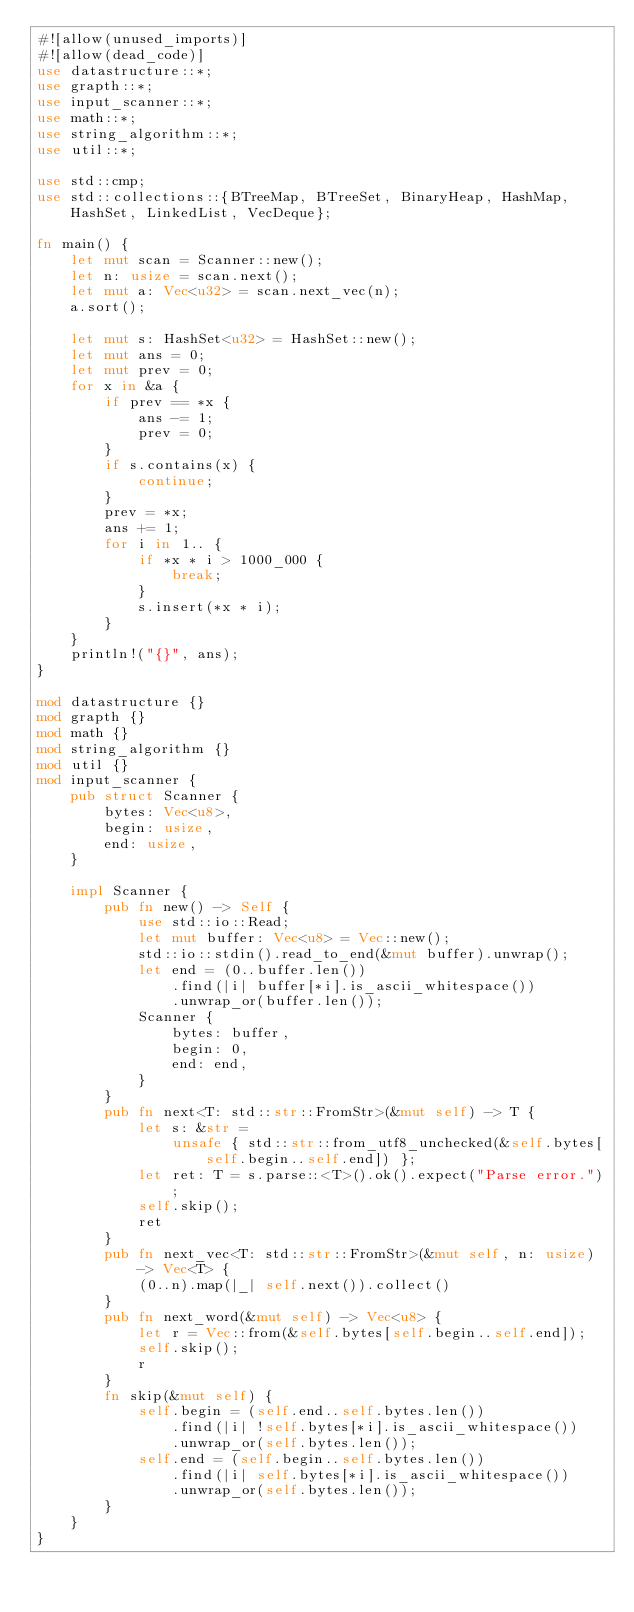Convert code to text. <code><loc_0><loc_0><loc_500><loc_500><_Rust_>#![allow(unused_imports)]
#![allow(dead_code)]
use datastructure::*;
use grapth::*;
use input_scanner::*;
use math::*;
use string_algorithm::*;
use util::*;

use std::cmp;
use std::collections::{BTreeMap, BTreeSet, BinaryHeap, HashMap, HashSet, LinkedList, VecDeque};

fn main() {
    let mut scan = Scanner::new();
    let n: usize = scan.next();
    let mut a: Vec<u32> = scan.next_vec(n);
    a.sort();

    let mut s: HashSet<u32> = HashSet::new();
    let mut ans = 0;
    let mut prev = 0;
    for x in &a {
        if prev == *x {
            ans -= 1;
            prev = 0;
        }
        if s.contains(x) {
            continue;
        }
        prev = *x;
        ans += 1;
        for i in 1.. {
            if *x * i > 1000_000 {
                break;
            }
            s.insert(*x * i);
        }
    }
    println!("{}", ans);
}

mod datastructure {}
mod grapth {}
mod math {}
mod string_algorithm {}
mod util {}
mod input_scanner {
    pub struct Scanner {
        bytes: Vec<u8>,
        begin: usize,
        end: usize,
    }

    impl Scanner {
        pub fn new() -> Self {
            use std::io::Read;
            let mut buffer: Vec<u8> = Vec::new();
            std::io::stdin().read_to_end(&mut buffer).unwrap();
            let end = (0..buffer.len())
                .find(|i| buffer[*i].is_ascii_whitespace())
                .unwrap_or(buffer.len());
            Scanner {
                bytes: buffer,
                begin: 0,
                end: end,
            }
        }
        pub fn next<T: std::str::FromStr>(&mut self) -> T {
            let s: &str =
                unsafe { std::str::from_utf8_unchecked(&self.bytes[self.begin..self.end]) };
            let ret: T = s.parse::<T>().ok().expect("Parse error.");
            self.skip();
            ret
        }
        pub fn next_vec<T: std::str::FromStr>(&mut self, n: usize) -> Vec<T> {
            (0..n).map(|_| self.next()).collect()
        }
        pub fn next_word(&mut self) -> Vec<u8> {
            let r = Vec::from(&self.bytes[self.begin..self.end]);
            self.skip();
            r
        }
        fn skip(&mut self) {
            self.begin = (self.end..self.bytes.len())
                .find(|i| !self.bytes[*i].is_ascii_whitespace())
                .unwrap_or(self.bytes.len());
            self.end = (self.begin..self.bytes.len())
                .find(|i| self.bytes[*i].is_ascii_whitespace())
                .unwrap_or(self.bytes.len());
        }
    }
}
</code> 